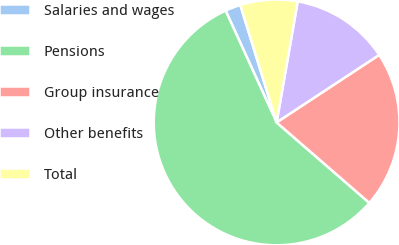Convert chart. <chart><loc_0><loc_0><loc_500><loc_500><pie_chart><fcel>Salaries and wages<fcel>Pensions<fcel>Group insurance<fcel>Other benefits<fcel>Total<nl><fcel>2.04%<fcel>56.82%<fcel>20.64%<fcel>12.99%<fcel>7.52%<nl></chart> 